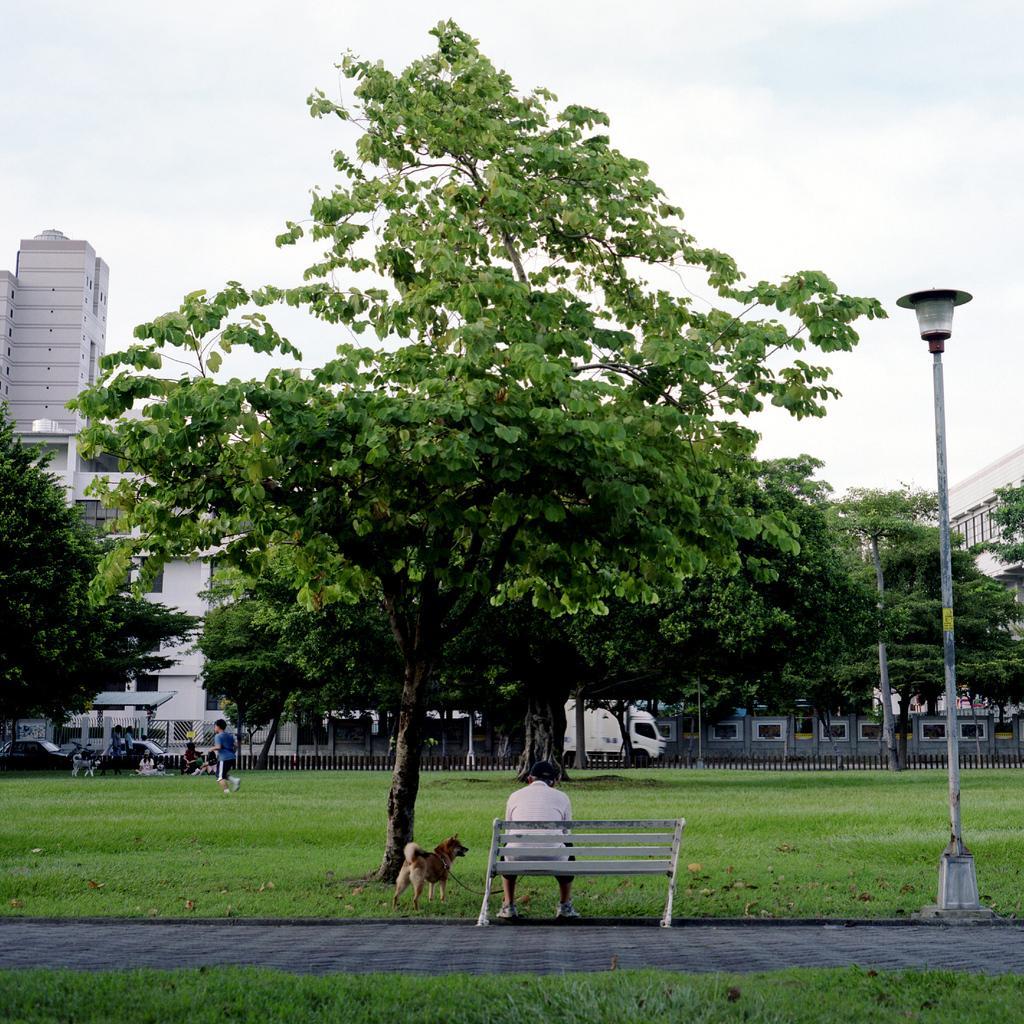Please provide a concise description of this image. The picture is taken outside the city. In the foreground of the picture there are grass, tree, bench, dog, man and a street pole. In the background there are trees, railing, people, vehicles and buildings. Sky is cloudy. 